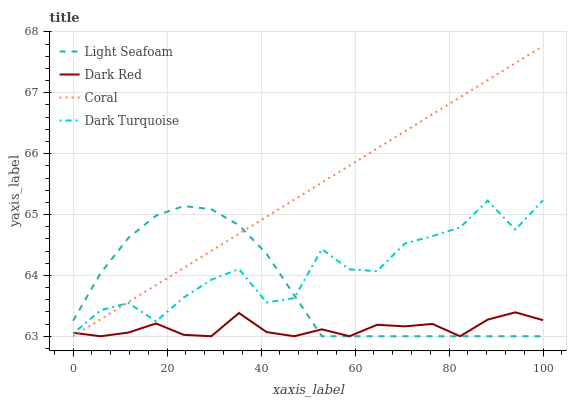Does Dark Red have the minimum area under the curve?
Answer yes or no. Yes. Does Coral have the maximum area under the curve?
Answer yes or no. Yes. Does Light Seafoam have the minimum area under the curve?
Answer yes or no. No. Does Light Seafoam have the maximum area under the curve?
Answer yes or no. No. Is Coral the smoothest?
Answer yes or no. Yes. Is Dark Turquoise the roughest?
Answer yes or no. Yes. Is Light Seafoam the smoothest?
Answer yes or no. No. Is Light Seafoam the roughest?
Answer yes or no. No. Does Dark Turquoise have the lowest value?
Answer yes or no. No. Does Light Seafoam have the highest value?
Answer yes or no. No. 